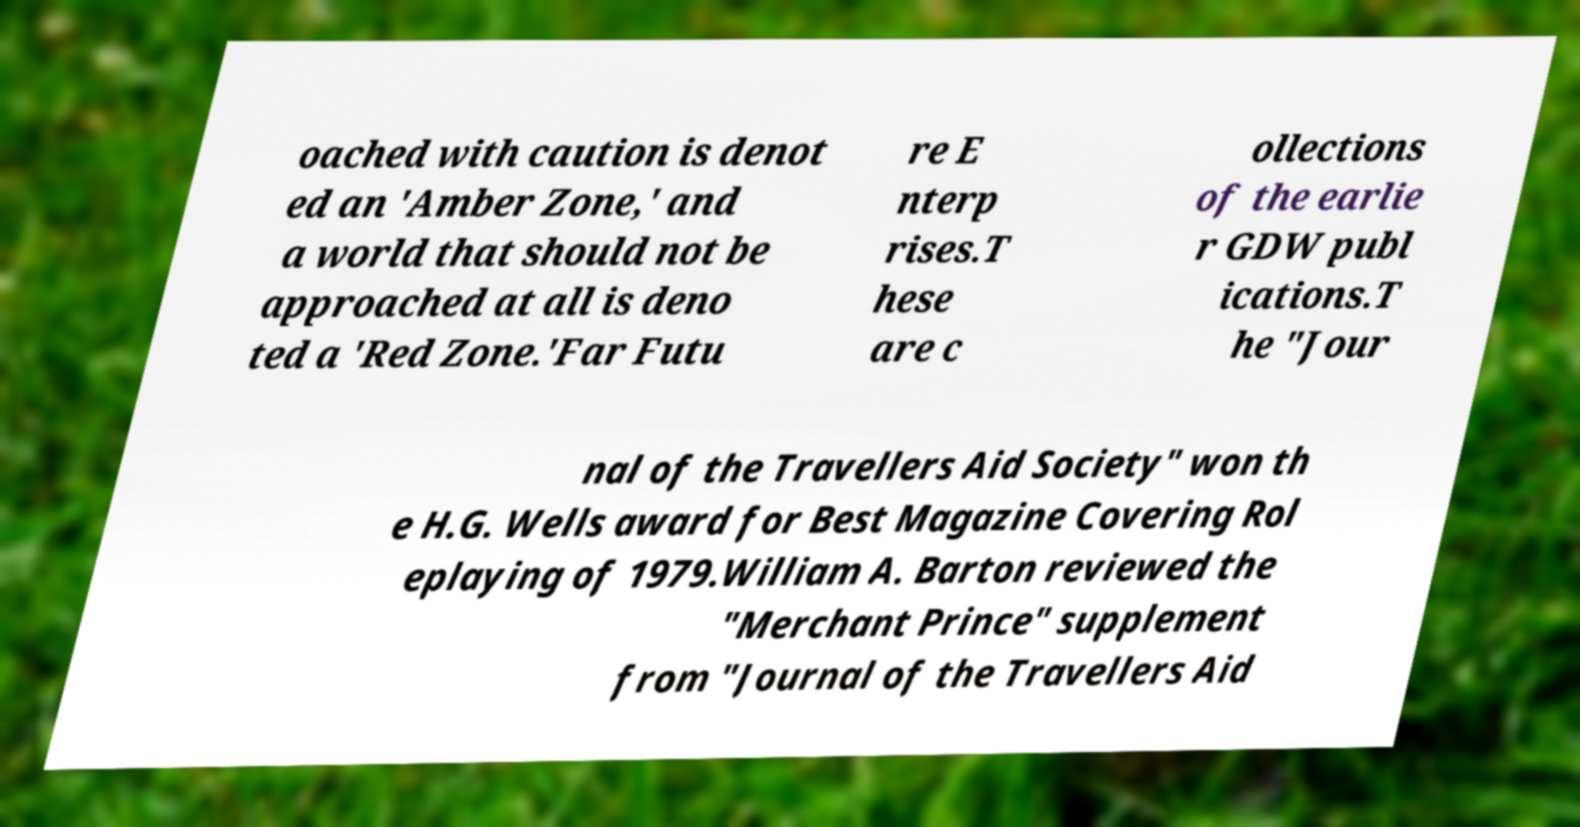Could you extract and type out the text from this image? oached with caution is denot ed an 'Amber Zone,' and a world that should not be approached at all is deno ted a 'Red Zone.'Far Futu re E nterp rises.T hese are c ollections of the earlie r GDW publ ications.T he "Jour nal of the Travellers Aid Society" won th e H.G. Wells award for Best Magazine Covering Rol eplaying of 1979.William A. Barton reviewed the "Merchant Prince" supplement from "Journal of the Travellers Aid 